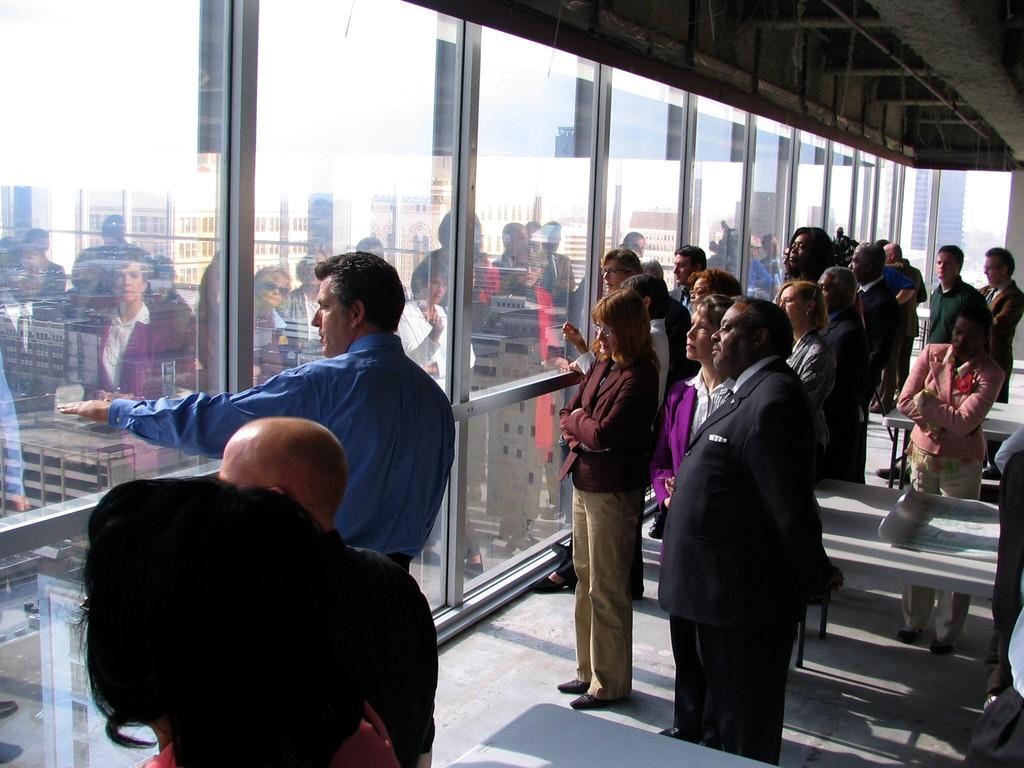Can you describe this image briefly? In the image there are many people standing on the floor in front of the glass wall and behind it there are many buildings on the land. 